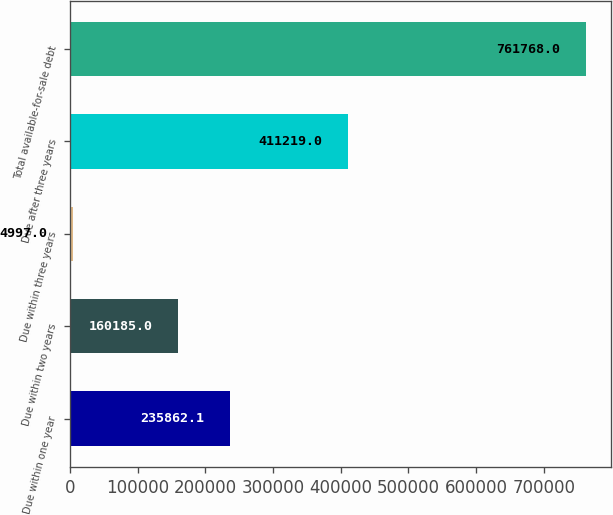<chart> <loc_0><loc_0><loc_500><loc_500><bar_chart><fcel>Due within one year<fcel>Due within two years<fcel>Due within three years<fcel>Due after three years<fcel>Total available-for-sale debt<nl><fcel>235862<fcel>160185<fcel>4997<fcel>411219<fcel>761768<nl></chart> 